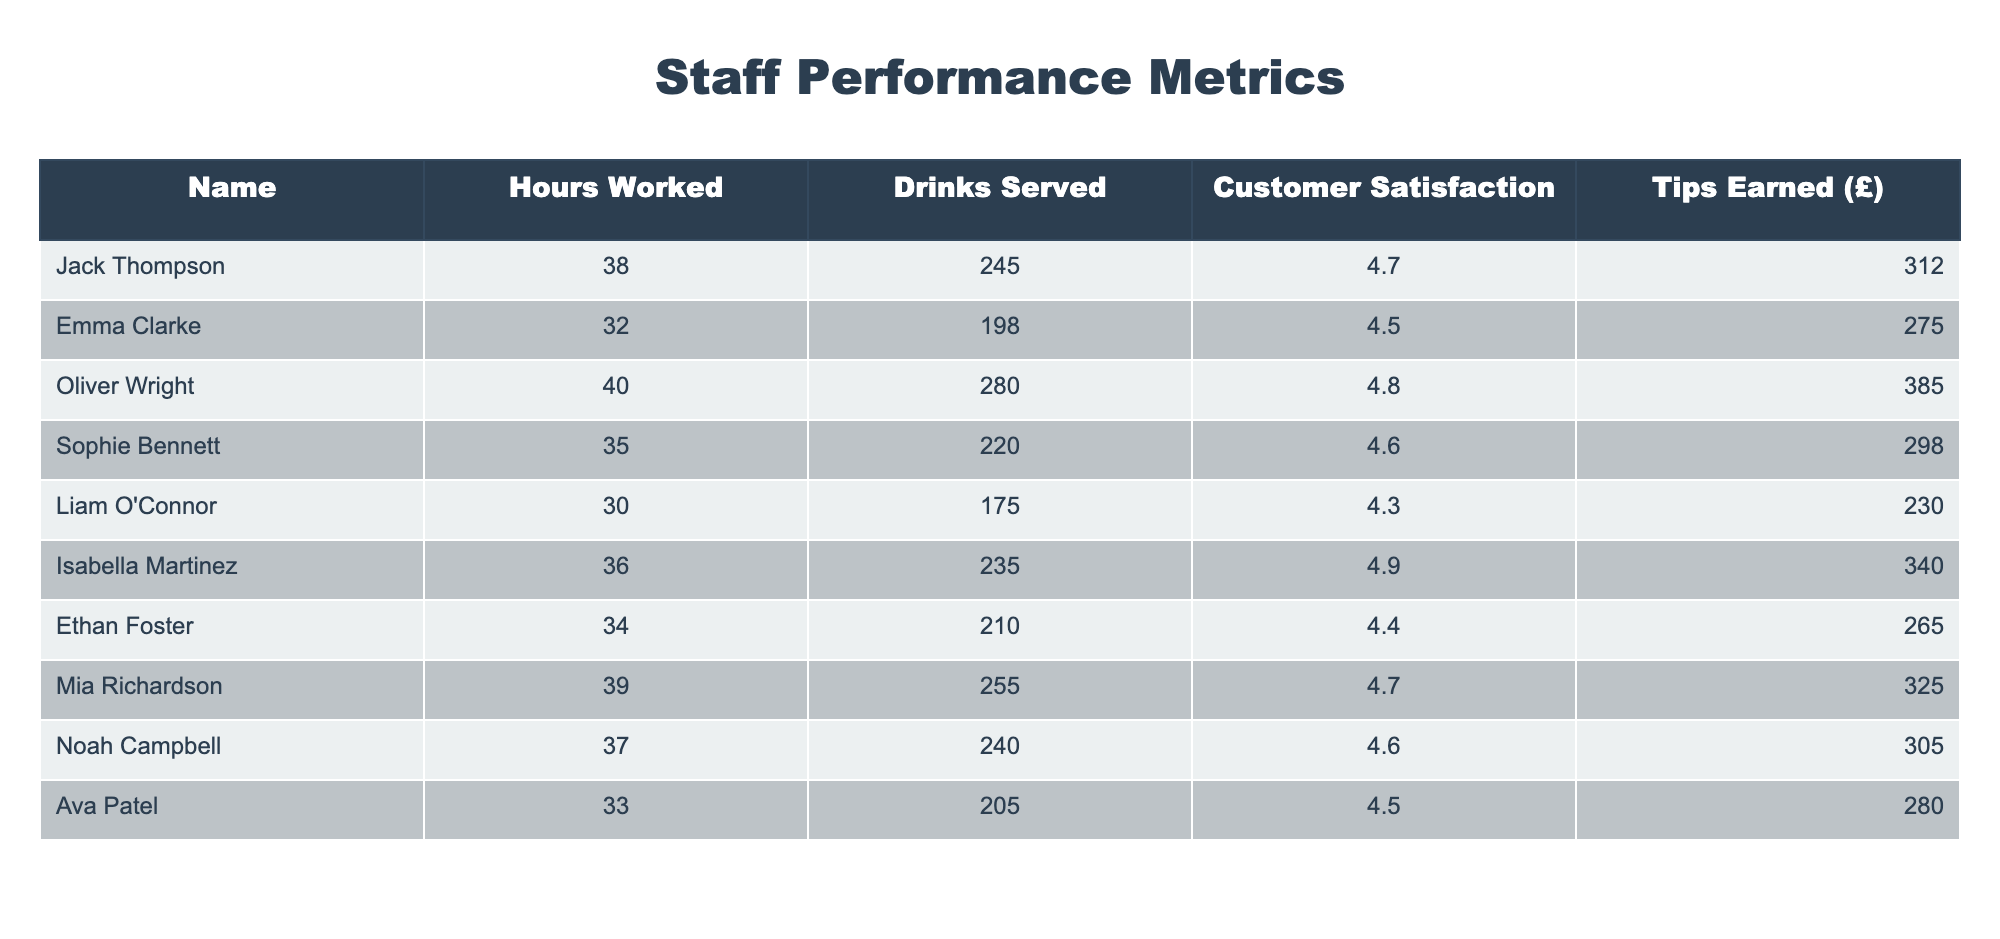What is the total amount of tips earned by all staff members combined? To find the total tips, I will sum the 'Tips Earned (£)' values of all staff members: 312 + 275 + 385 + 298 + 230 + 340 + 265 + 325 + 305 + 280 = 2,765.
Answer: 2765 Who earned the highest tips and how much were they? By comparing the 'Tips Earned (£)' values, Oliver Wright earned the highest tips at 385.
Answer: Oliver Wright; 385 What is the average customer satisfaction rating for the staff? To calculate the average, I will sum the 'Customer Satisfaction' values (4.7 + 4.5 + 4.8 + 4.6 + 4.3 + 4.9 + 4.4 + 4.7 + 4.6 + 4.5 = 46.0) and divide by the number of staff (10). The average rating is 46.0 / 10 = 4.6.
Answer: 4.6 Did any staff member work more than 38 hours and earn less than 300 in tips? Checking the data reveals that Liam O'Connor worked 30 hours and earned 230, while others who worked more hours (e.g., Jack Thompson and Sophie Bennett) earned more than 300 in tips. Hence, no staff member meets the criteria of >38 hours and <300 in tips.
Answer: No Is there a staff member whose customer satisfaction rating is lower than 4.4? Upon reviewing the customer satisfaction ratings, Liam O'Connor has a rating of 4.3, which is lower than 4.4, confirming the statement is true.
Answer: Yes Which staff member served the most drinks and what was the customer satisfaction rating for them? By examining the 'Drinks Served' column, Oliver Wright served the most drinks (280), and checking the 'Customer Satisfaction' column indicates a rating of 4.8.
Answer: Oliver Wright; 4.8 What is the combined amount of tips earned by staff members who served more than 220 drinks? Filtering the table for staff who served more than 220 drinks: Jack Thompson (312), Oliver Wright (385), Sophie Bennett (298), Isabella Martinez (340), Mia Richardson (325), Noah Campbell (305). Their total tips are 312 + 385 + 298 + 340 + 325 + 305 = 1,945.
Answer: 1945 What percentage of the total hours worked does Mia Richardson represent? First, calculate the total hours worked by all staff (38 + 32 + 40 + 35 + 30 + 36 + 34 + 39 + 37 + 33 =  374). Then find Mia's hours (39) and calculate the percentage: (39 / 374) * 100 = approximately 10.42%.
Answer: 10.42% 